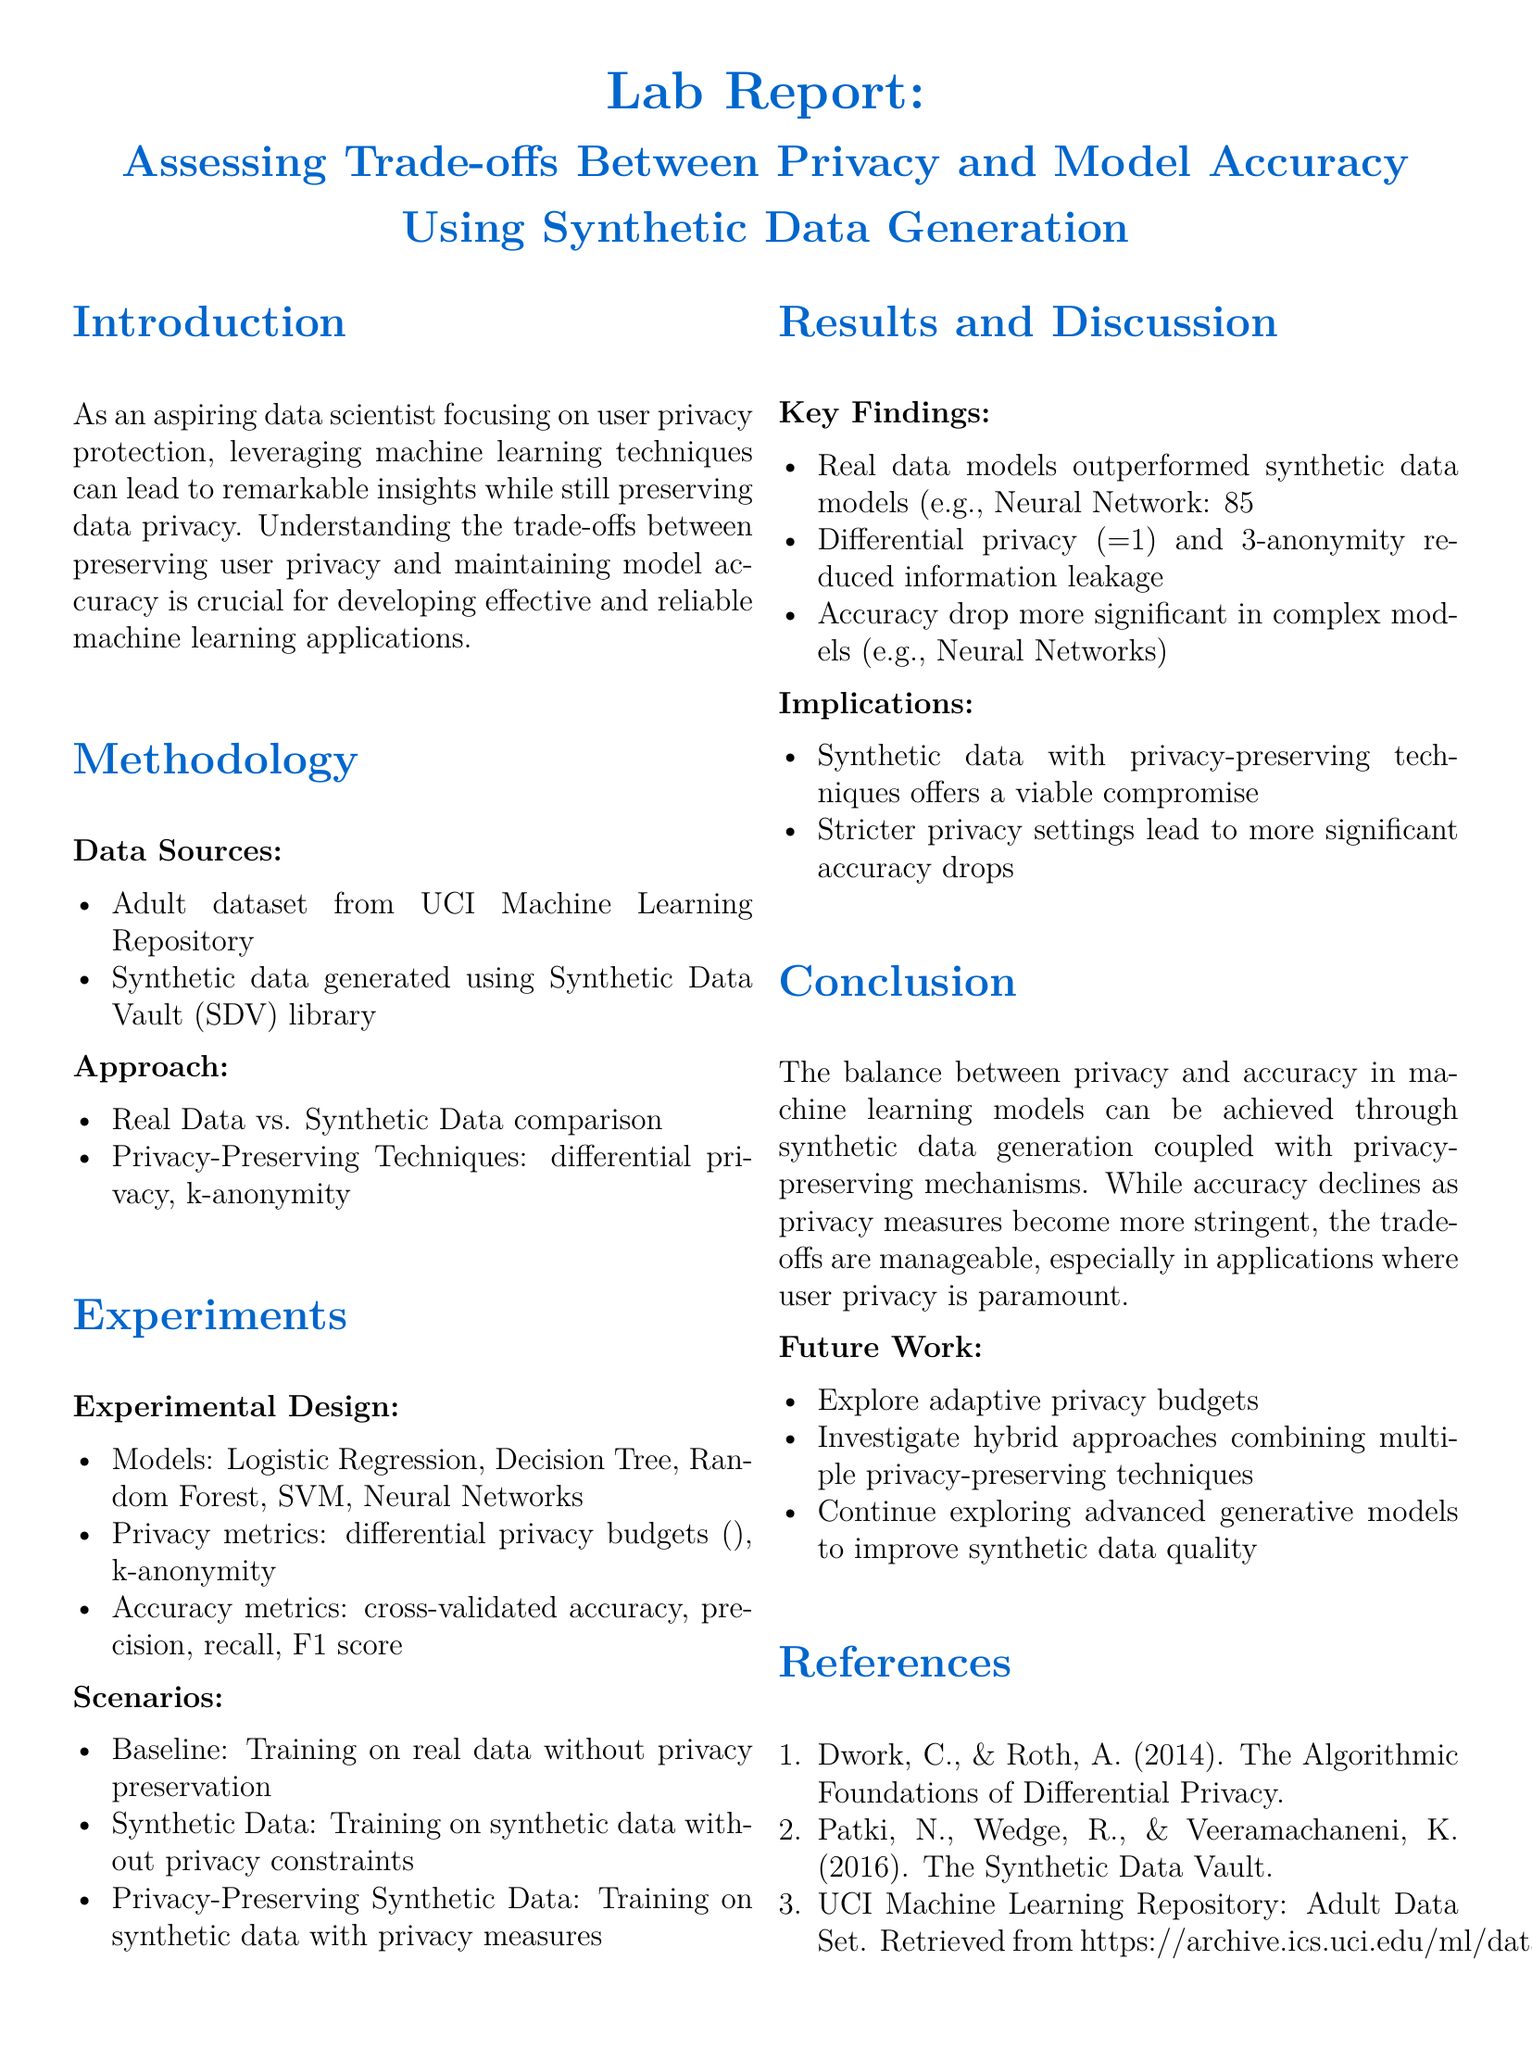What is the main focus of the lab report? The main focus of the lab report is to assess the trade-offs between privacy and model accuracy using synthetic data generation for privacy-preserving machine learning.
Answer: Assessing the trade-offs between privacy and model accuracy Which dataset was used from the UCI Machine Learning Repository? The dataset used from the UCI Machine Learning Repository is the Adult dataset.
Answer: Adult dataset What privacy metric was used in the experiments? The privacy metric used in the experiments includes differential privacy budgets.
Answer: Differential privacy budgets What is the accuracy of the Neural Network model on real data? The accuracy of the Neural Network model on real data is 85%.
Answer: 85% What technique reduced information leakage in the study? Differential privacy and k-anonymity were the techniques that reduced information leakage.
Answer: Differential privacy and k-anonymity How much accuracy did synthetic data models achieve compared to real data models? Synthetic data models achieved an accuracy of 78% compared to real data models at 85%.
Answer: 78% What did stricter privacy settings lead to? Stricter privacy settings led to more significant accuracy drops.
Answer: More significant accuracy drops What type of experimental design was used for model evaluation? Models were evaluated using cross-validated accuracy, precision, recall, and F1 score as part of the experimental design.
Answer: Cross-validated accuracy, precision, recall, F1 score 